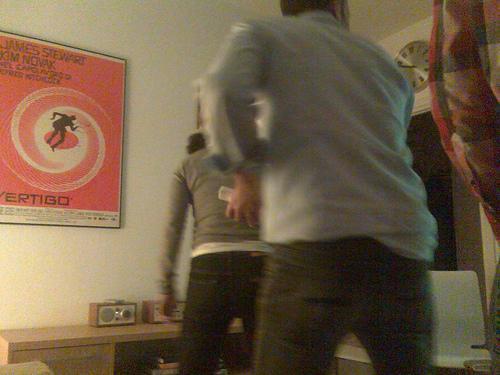What form of vintage media do the people in the living room enjoy?
Pick the correct solution from the four options below to address the question.
Options: Music, movies, paintings, books. Movies. 